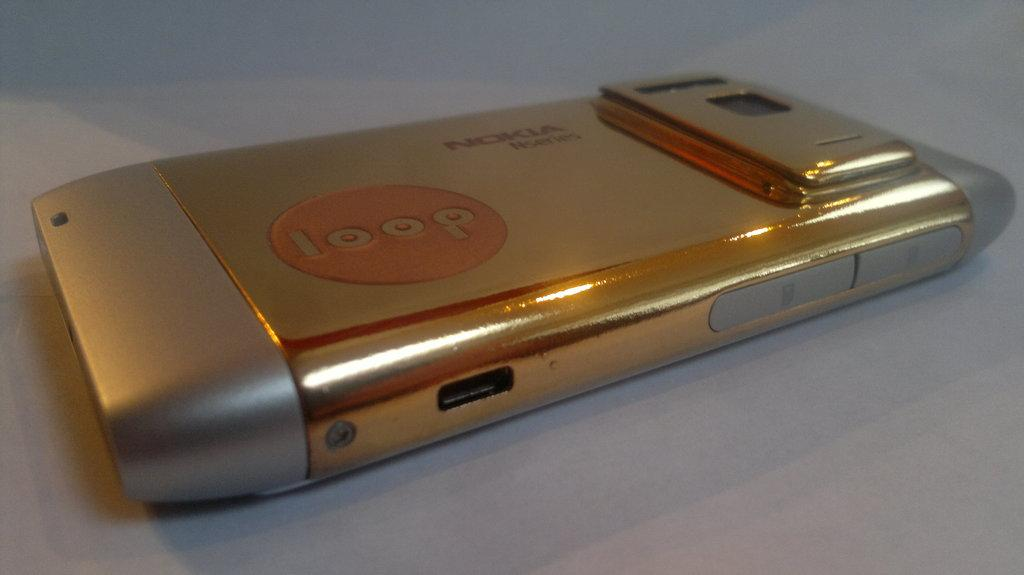<image>
Summarize the visual content of the image. A gold and silver Nokia phone with a red loop logo. 